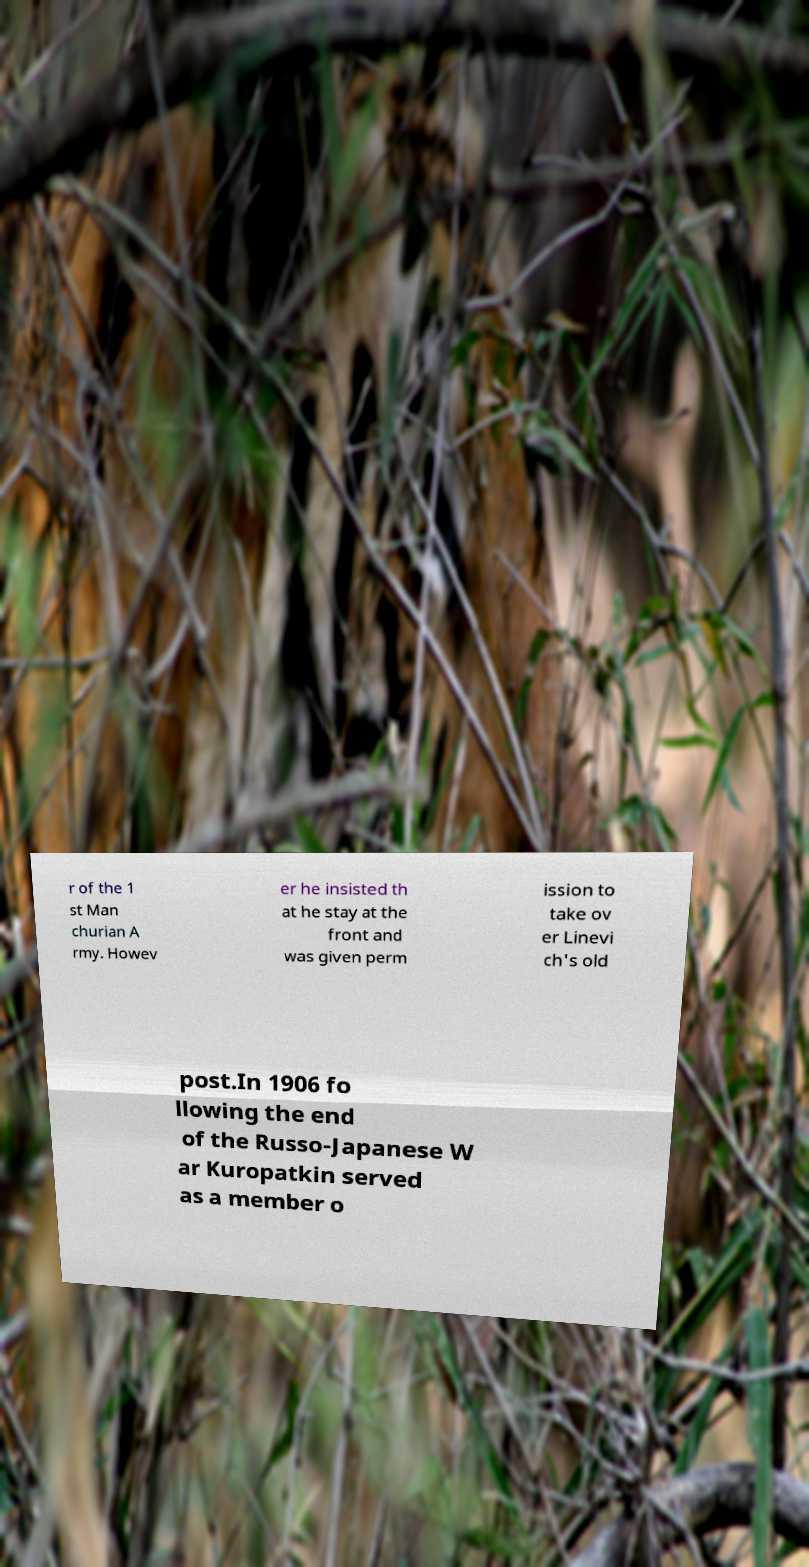Could you extract and type out the text from this image? r of the 1 st Man churian A rmy. Howev er he insisted th at he stay at the front and was given perm ission to take ov er Linevi ch's old post.In 1906 fo llowing the end of the Russo-Japanese W ar Kuropatkin served as a member o 